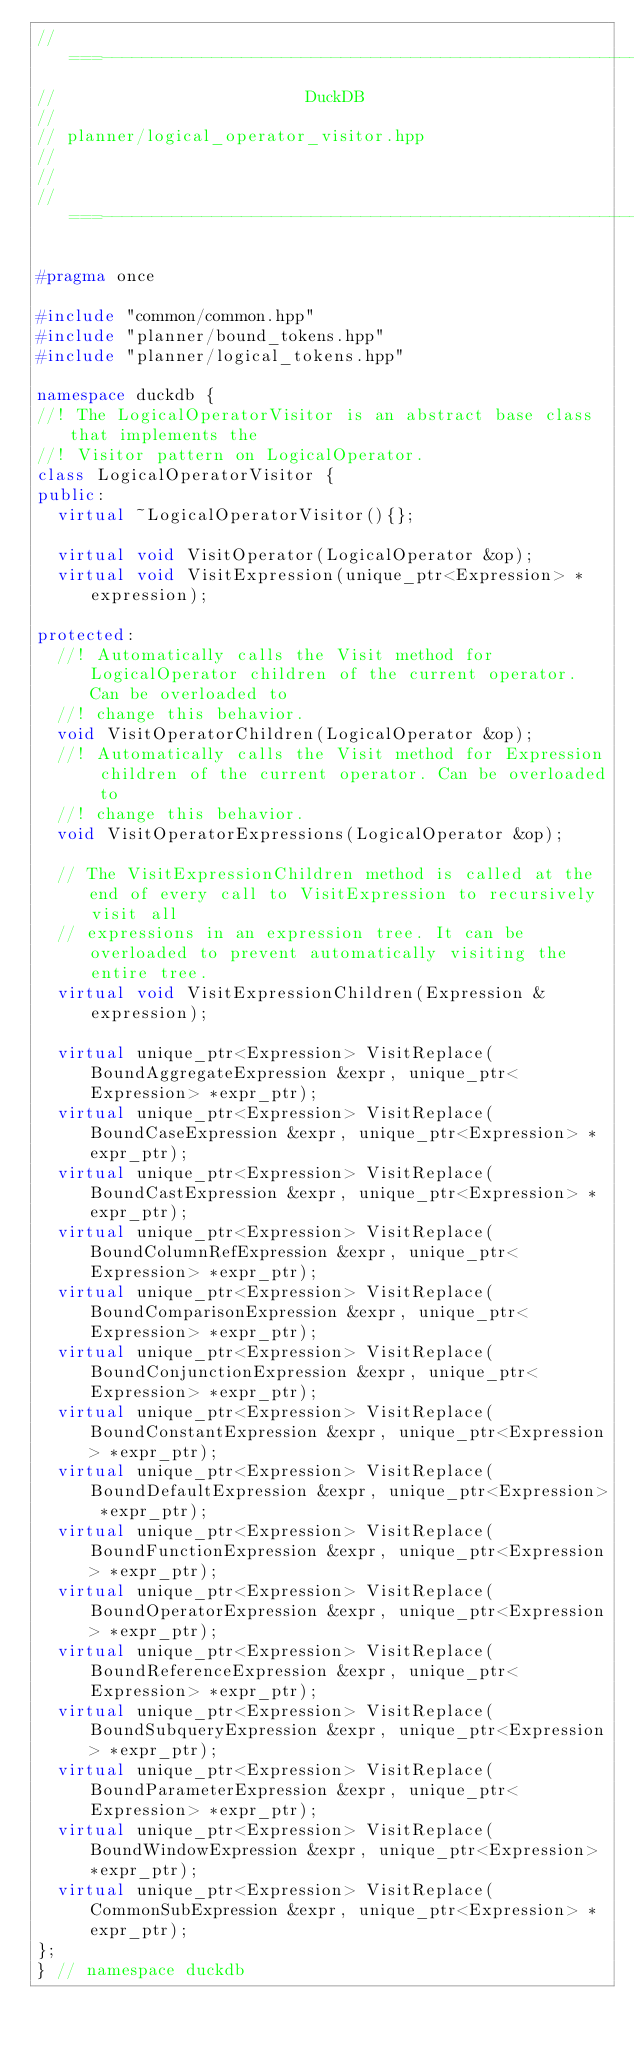<code> <loc_0><loc_0><loc_500><loc_500><_C++_>//===----------------------------------------------------------------------===//
//                         DuckDB
//
// planner/logical_operator_visitor.hpp
//
//
//===----------------------------------------------------------------------===//

#pragma once

#include "common/common.hpp"
#include "planner/bound_tokens.hpp"
#include "planner/logical_tokens.hpp"

namespace duckdb {
//! The LogicalOperatorVisitor is an abstract base class that implements the
//! Visitor pattern on LogicalOperator.
class LogicalOperatorVisitor {
public:
	virtual ~LogicalOperatorVisitor(){};

	virtual void VisitOperator(LogicalOperator &op);
	virtual void VisitExpression(unique_ptr<Expression> *expression);

protected:
	//! Automatically calls the Visit method for LogicalOperator children of the current operator. Can be overloaded to
	//! change this behavior.
	void VisitOperatorChildren(LogicalOperator &op);
	//! Automatically calls the Visit method for Expression children of the current operator. Can be overloaded to
	//! change this behavior.
	void VisitOperatorExpressions(LogicalOperator &op);

	// The VisitExpressionChildren method is called at the end of every call to VisitExpression to recursively visit all
	// expressions in an expression tree. It can be overloaded to prevent automatically visiting the entire tree.
	virtual void VisitExpressionChildren(Expression &expression);

	virtual unique_ptr<Expression> VisitReplace(BoundAggregateExpression &expr, unique_ptr<Expression> *expr_ptr);
	virtual unique_ptr<Expression> VisitReplace(BoundCaseExpression &expr, unique_ptr<Expression> *expr_ptr);
	virtual unique_ptr<Expression> VisitReplace(BoundCastExpression &expr, unique_ptr<Expression> *expr_ptr);
	virtual unique_ptr<Expression> VisitReplace(BoundColumnRefExpression &expr, unique_ptr<Expression> *expr_ptr);
	virtual unique_ptr<Expression> VisitReplace(BoundComparisonExpression &expr, unique_ptr<Expression> *expr_ptr);
	virtual unique_ptr<Expression> VisitReplace(BoundConjunctionExpression &expr, unique_ptr<Expression> *expr_ptr);
	virtual unique_ptr<Expression> VisitReplace(BoundConstantExpression &expr, unique_ptr<Expression> *expr_ptr);
	virtual unique_ptr<Expression> VisitReplace(BoundDefaultExpression &expr, unique_ptr<Expression> *expr_ptr);
	virtual unique_ptr<Expression> VisitReplace(BoundFunctionExpression &expr, unique_ptr<Expression> *expr_ptr);
	virtual unique_ptr<Expression> VisitReplace(BoundOperatorExpression &expr, unique_ptr<Expression> *expr_ptr);
	virtual unique_ptr<Expression> VisitReplace(BoundReferenceExpression &expr, unique_ptr<Expression> *expr_ptr);
	virtual unique_ptr<Expression> VisitReplace(BoundSubqueryExpression &expr, unique_ptr<Expression> *expr_ptr);
	virtual unique_ptr<Expression> VisitReplace(BoundParameterExpression &expr, unique_ptr<Expression> *expr_ptr);
	virtual unique_ptr<Expression> VisitReplace(BoundWindowExpression &expr, unique_ptr<Expression> *expr_ptr);
	virtual unique_ptr<Expression> VisitReplace(CommonSubExpression &expr, unique_ptr<Expression> *expr_ptr);
};
} // namespace duckdb
</code> 